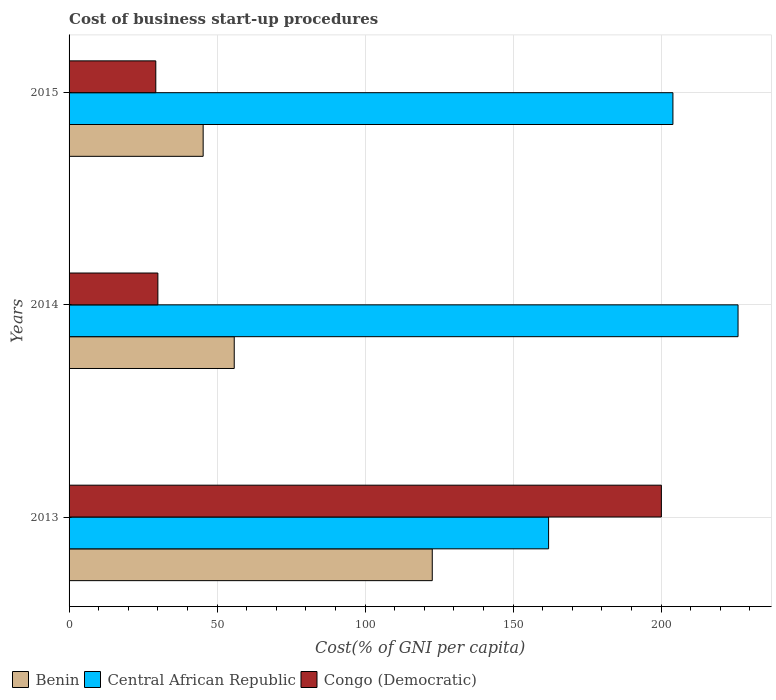Are the number of bars on each tick of the Y-axis equal?
Make the answer very short. Yes. What is the label of the 3rd group of bars from the top?
Your response must be concise. 2013. What is the cost of business start-up procedures in Central African Republic in 2014?
Provide a short and direct response. 226. Across all years, what is the maximum cost of business start-up procedures in Congo (Democratic)?
Your response must be concise. 200.1. Across all years, what is the minimum cost of business start-up procedures in Central African Republic?
Your answer should be compact. 162. In which year was the cost of business start-up procedures in Congo (Democratic) maximum?
Provide a succinct answer. 2013. What is the total cost of business start-up procedures in Central African Republic in the graph?
Offer a terse response. 592. What is the difference between the cost of business start-up procedures in Central African Republic in 2013 and that in 2015?
Ensure brevity in your answer.  -42. What is the difference between the cost of business start-up procedures in Congo (Democratic) in 2013 and the cost of business start-up procedures in Benin in 2015?
Your answer should be very brief. 154.8. What is the average cost of business start-up procedures in Congo (Democratic) per year?
Provide a succinct answer. 86.47. In the year 2014, what is the difference between the cost of business start-up procedures in Benin and cost of business start-up procedures in Central African Republic?
Your answer should be compact. -170.2. In how many years, is the cost of business start-up procedures in Congo (Democratic) greater than 160 %?
Provide a succinct answer. 1. What is the ratio of the cost of business start-up procedures in Benin in 2014 to that in 2015?
Provide a succinct answer. 1.23. In how many years, is the cost of business start-up procedures in Congo (Democratic) greater than the average cost of business start-up procedures in Congo (Democratic) taken over all years?
Keep it short and to the point. 1. What does the 1st bar from the top in 2015 represents?
Ensure brevity in your answer.  Congo (Democratic). What does the 2nd bar from the bottom in 2015 represents?
Make the answer very short. Central African Republic. Is it the case that in every year, the sum of the cost of business start-up procedures in Central African Republic and cost of business start-up procedures in Congo (Democratic) is greater than the cost of business start-up procedures in Benin?
Make the answer very short. Yes. Are all the bars in the graph horizontal?
Give a very brief answer. Yes. Does the graph contain any zero values?
Provide a succinct answer. No. What is the title of the graph?
Offer a terse response. Cost of business start-up procedures. What is the label or title of the X-axis?
Ensure brevity in your answer.  Cost(% of GNI per capita). What is the Cost(% of GNI per capita) in Benin in 2013?
Offer a very short reply. 122.7. What is the Cost(% of GNI per capita) of Central African Republic in 2013?
Offer a terse response. 162. What is the Cost(% of GNI per capita) in Congo (Democratic) in 2013?
Your answer should be very brief. 200.1. What is the Cost(% of GNI per capita) in Benin in 2014?
Keep it short and to the point. 55.8. What is the Cost(% of GNI per capita) in Central African Republic in 2014?
Your answer should be very brief. 226. What is the Cost(% of GNI per capita) in Benin in 2015?
Your answer should be compact. 45.3. What is the Cost(% of GNI per capita) of Central African Republic in 2015?
Make the answer very short. 204. What is the Cost(% of GNI per capita) of Congo (Democratic) in 2015?
Offer a very short reply. 29.3. Across all years, what is the maximum Cost(% of GNI per capita) of Benin?
Your answer should be very brief. 122.7. Across all years, what is the maximum Cost(% of GNI per capita) in Central African Republic?
Your response must be concise. 226. Across all years, what is the maximum Cost(% of GNI per capita) in Congo (Democratic)?
Ensure brevity in your answer.  200.1. Across all years, what is the minimum Cost(% of GNI per capita) of Benin?
Offer a very short reply. 45.3. Across all years, what is the minimum Cost(% of GNI per capita) of Central African Republic?
Your response must be concise. 162. Across all years, what is the minimum Cost(% of GNI per capita) in Congo (Democratic)?
Offer a very short reply. 29.3. What is the total Cost(% of GNI per capita) in Benin in the graph?
Your answer should be very brief. 223.8. What is the total Cost(% of GNI per capita) in Central African Republic in the graph?
Your answer should be compact. 592. What is the total Cost(% of GNI per capita) in Congo (Democratic) in the graph?
Ensure brevity in your answer.  259.4. What is the difference between the Cost(% of GNI per capita) in Benin in 2013 and that in 2014?
Ensure brevity in your answer.  66.9. What is the difference between the Cost(% of GNI per capita) of Central African Republic in 2013 and that in 2014?
Provide a short and direct response. -64. What is the difference between the Cost(% of GNI per capita) in Congo (Democratic) in 2013 and that in 2014?
Provide a short and direct response. 170.1. What is the difference between the Cost(% of GNI per capita) of Benin in 2013 and that in 2015?
Give a very brief answer. 77.4. What is the difference between the Cost(% of GNI per capita) in Central African Republic in 2013 and that in 2015?
Keep it short and to the point. -42. What is the difference between the Cost(% of GNI per capita) in Congo (Democratic) in 2013 and that in 2015?
Offer a very short reply. 170.8. What is the difference between the Cost(% of GNI per capita) of Benin in 2014 and that in 2015?
Offer a terse response. 10.5. What is the difference between the Cost(% of GNI per capita) of Congo (Democratic) in 2014 and that in 2015?
Your answer should be compact. 0.7. What is the difference between the Cost(% of GNI per capita) in Benin in 2013 and the Cost(% of GNI per capita) in Central African Republic in 2014?
Ensure brevity in your answer.  -103.3. What is the difference between the Cost(% of GNI per capita) in Benin in 2013 and the Cost(% of GNI per capita) in Congo (Democratic) in 2014?
Provide a short and direct response. 92.7. What is the difference between the Cost(% of GNI per capita) in Central African Republic in 2013 and the Cost(% of GNI per capita) in Congo (Democratic) in 2014?
Provide a short and direct response. 132. What is the difference between the Cost(% of GNI per capita) in Benin in 2013 and the Cost(% of GNI per capita) in Central African Republic in 2015?
Your answer should be very brief. -81.3. What is the difference between the Cost(% of GNI per capita) of Benin in 2013 and the Cost(% of GNI per capita) of Congo (Democratic) in 2015?
Offer a very short reply. 93.4. What is the difference between the Cost(% of GNI per capita) of Central African Republic in 2013 and the Cost(% of GNI per capita) of Congo (Democratic) in 2015?
Ensure brevity in your answer.  132.7. What is the difference between the Cost(% of GNI per capita) in Benin in 2014 and the Cost(% of GNI per capita) in Central African Republic in 2015?
Make the answer very short. -148.2. What is the difference between the Cost(% of GNI per capita) in Central African Republic in 2014 and the Cost(% of GNI per capita) in Congo (Democratic) in 2015?
Make the answer very short. 196.7. What is the average Cost(% of GNI per capita) in Benin per year?
Keep it short and to the point. 74.6. What is the average Cost(% of GNI per capita) of Central African Republic per year?
Your answer should be very brief. 197.33. What is the average Cost(% of GNI per capita) of Congo (Democratic) per year?
Provide a succinct answer. 86.47. In the year 2013, what is the difference between the Cost(% of GNI per capita) in Benin and Cost(% of GNI per capita) in Central African Republic?
Your response must be concise. -39.3. In the year 2013, what is the difference between the Cost(% of GNI per capita) in Benin and Cost(% of GNI per capita) in Congo (Democratic)?
Ensure brevity in your answer.  -77.4. In the year 2013, what is the difference between the Cost(% of GNI per capita) of Central African Republic and Cost(% of GNI per capita) of Congo (Democratic)?
Provide a short and direct response. -38.1. In the year 2014, what is the difference between the Cost(% of GNI per capita) in Benin and Cost(% of GNI per capita) in Central African Republic?
Offer a terse response. -170.2. In the year 2014, what is the difference between the Cost(% of GNI per capita) of Benin and Cost(% of GNI per capita) of Congo (Democratic)?
Ensure brevity in your answer.  25.8. In the year 2014, what is the difference between the Cost(% of GNI per capita) of Central African Republic and Cost(% of GNI per capita) of Congo (Democratic)?
Your answer should be very brief. 196. In the year 2015, what is the difference between the Cost(% of GNI per capita) in Benin and Cost(% of GNI per capita) in Central African Republic?
Provide a succinct answer. -158.7. In the year 2015, what is the difference between the Cost(% of GNI per capita) of Benin and Cost(% of GNI per capita) of Congo (Democratic)?
Provide a short and direct response. 16. In the year 2015, what is the difference between the Cost(% of GNI per capita) of Central African Republic and Cost(% of GNI per capita) of Congo (Democratic)?
Give a very brief answer. 174.7. What is the ratio of the Cost(% of GNI per capita) of Benin in 2013 to that in 2014?
Keep it short and to the point. 2.2. What is the ratio of the Cost(% of GNI per capita) of Central African Republic in 2013 to that in 2014?
Give a very brief answer. 0.72. What is the ratio of the Cost(% of GNI per capita) in Congo (Democratic) in 2013 to that in 2014?
Give a very brief answer. 6.67. What is the ratio of the Cost(% of GNI per capita) of Benin in 2013 to that in 2015?
Make the answer very short. 2.71. What is the ratio of the Cost(% of GNI per capita) of Central African Republic in 2013 to that in 2015?
Provide a short and direct response. 0.79. What is the ratio of the Cost(% of GNI per capita) of Congo (Democratic) in 2013 to that in 2015?
Keep it short and to the point. 6.83. What is the ratio of the Cost(% of GNI per capita) in Benin in 2014 to that in 2015?
Ensure brevity in your answer.  1.23. What is the ratio of the Cost(% of GNI per capita) of Central African Republic in 2014 to that in 2015?
Your response must be concise. 1.11. What is the ratio of the Cost(% of GNI per capita) in Congo (Democratic) in 2014 to that in 2015?
Your answer should be compact. 1.02. What is the difference between the highest and the second highest Cost(% of GNI per capita) in Benin?
Provide a short and direct response. 66.9. What is the difference between the highest and the second highest Cost(% of GNI per capita) in Congo (Democratic)?
Provide a succinct answer. 170.1. What is the difference between the highest and the lowest Cost(% of GNI per capita) of Benin?
Offer a terse response. 77.4. What is the difference between the highest and the lowest Cost(% of GNI per capita) in Central African Republic?
Provide a succinct answer. 64. What is the difference between the highest and the lowest Cost(% of GNI per capita) in Congo (Democratic)?
Keep it short and to the point. 170.8. 